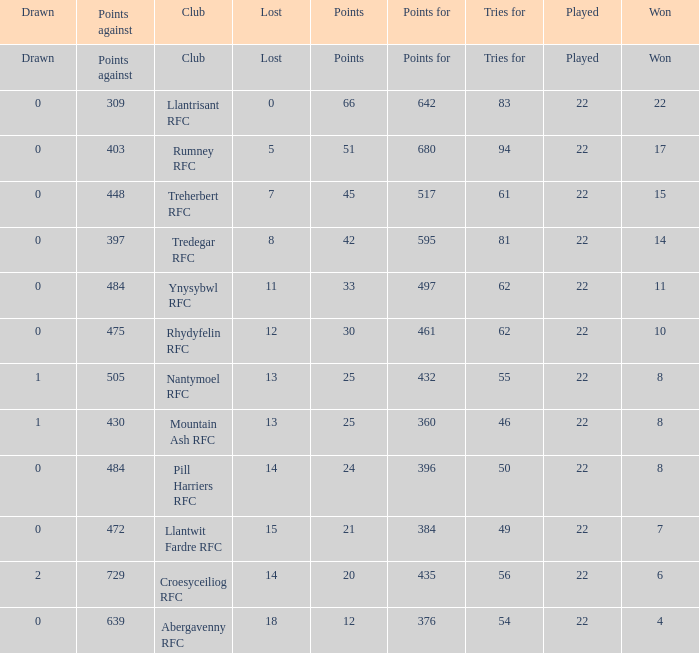How many points for were scored by the team that won exactly 22? 642.0. 